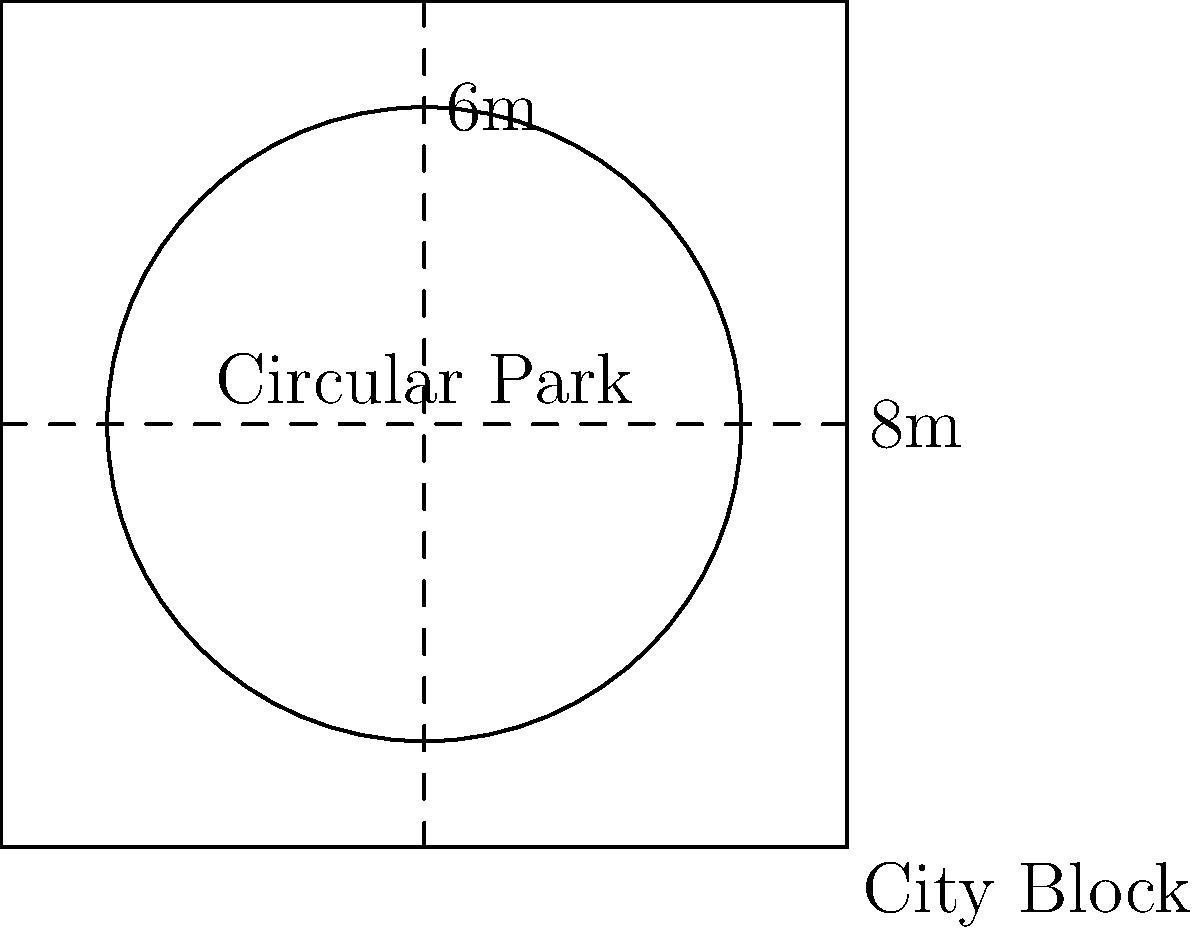In a modern urban development project, a circular park is being planned within a square city block. The city block measures 8 meters on each side, and the diameter of the circular park is 6 meters. What is the area of the circular park in square meters? Round your answer to two decimal places. To find the area of the circular park, we'll follow these steps:

1) First, recall the formula for the area of a circle:
   $$A = \pi r^2$$
   where $A$ is the area and $r$ is the radius.

2) We're given the diameter of the park, which is 6 meters. The radius is half of this:
   $$r = \frac{6}{2} = 3 \text{ meters}$$

3) Now we can substitute this into our formula:
   $$A = \pi (3)^2$$

4) Simplify:
   $$A = 9\pi \text{ square meters}$$

5) Using $\pi \approx 3.14159$, we get:
   $$A \approx 9 * 3.14159 = 28.27431 \text{ square meters}$$

6) Rounding to two decimal places:
   $$A \approx 28.27 \text{ square meters}$$
Answer: $28.27 \text{ m}^2$ 